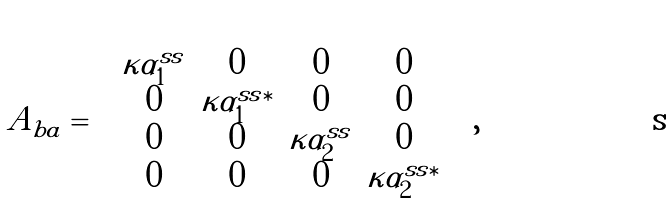<formula> <loc_0><loc_0><loc_500><loc_500>A _ { b a } = \left [ \begin{array} { c c c c } \kappa \alpha _ { 1 } ^ { s s } & 0 & 0 & 0 \\ 0 & \kappa \alpha _ { 1 } ^ { s s \ast } & 0 & 0 \\ 0 & 0 & \kappa \alpha _ { 2 } ^ { s s } & 0 \\ 0 & 0 & 0 & \kappa \alpha _ { 2 } ^ { s s \ast } \end{array} \right ] ,</formula> 